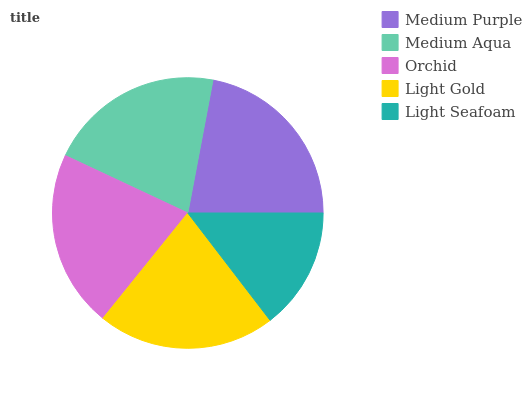Is Light Seafoam the minimum?
Answer yes or no. Yes. Is Medium Purple the maximum?
Answer yes or no. Yes. Is Medium Aqua the minimum?
Answer yes or no. No. Is Medium Aqua the maximum?
Answer yes or no. No. Is Medium Purple greater than Medium Aqua?
Answer yes or no. Yes. Is Medium Aqua less than Medium Purple?
Answer yes or no. Yes. Is Medium Aqua greater than Medium Purple?
Answer yes or no. No. Is Medium Purple less than Medium Aqua?
Answer yes or no. No. Is Orchid the high median?
Answer yes or no. Yes. Is Orchid the low median?
Answer yes or no. Yes. Is Medium Aqua the high median?
Answer yes or no. No. Is Light Gold the low median?
Answer yes or no. No. 